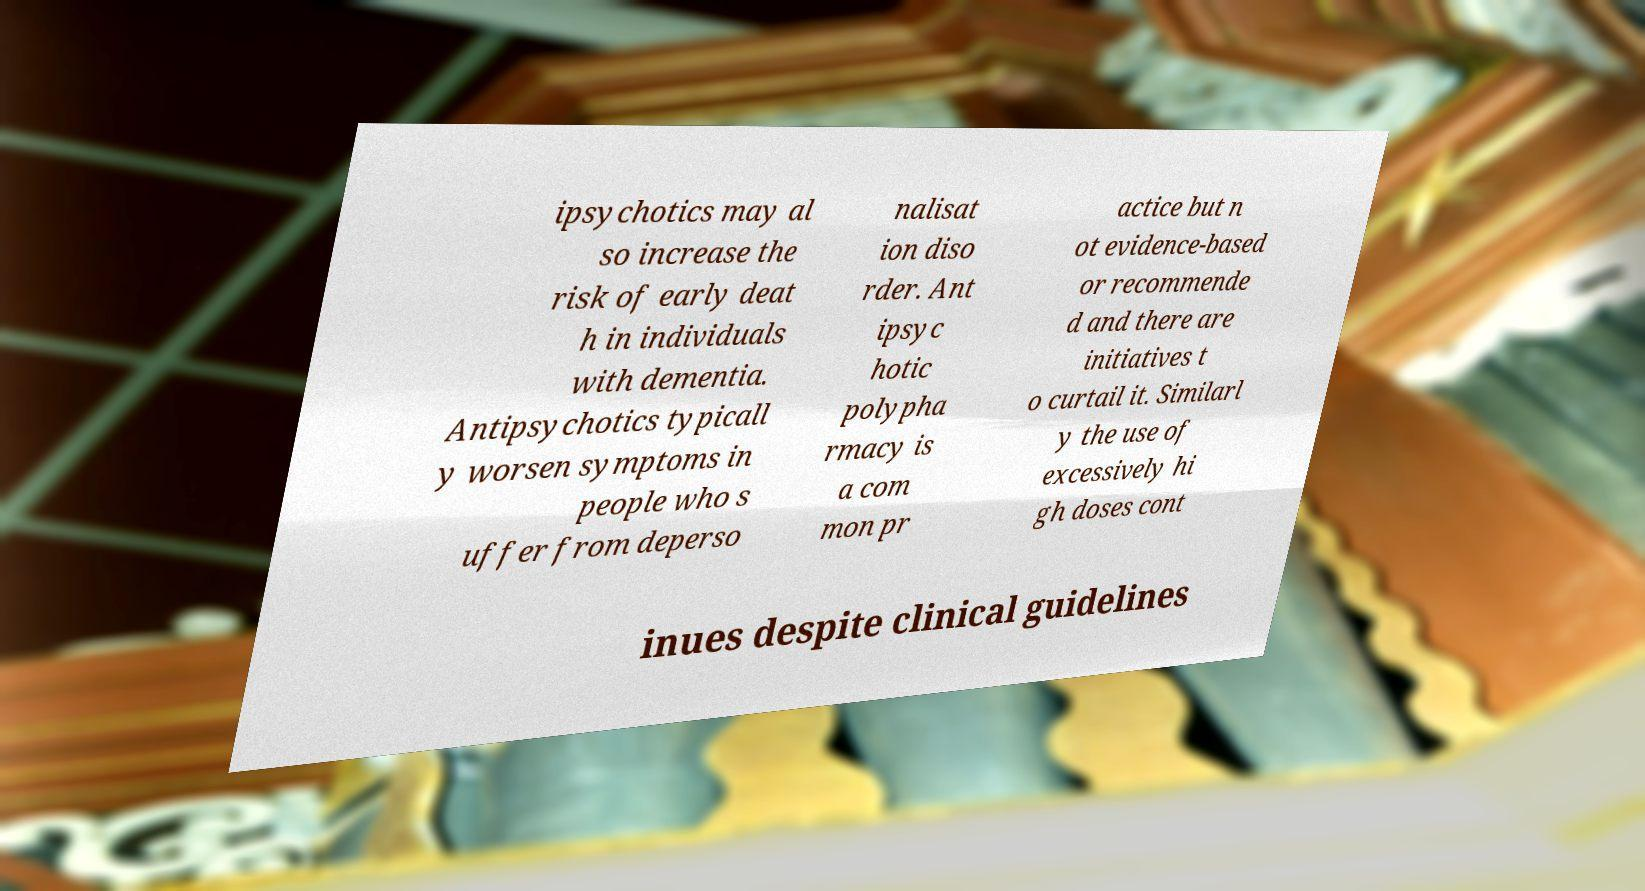Could you assist in decoding the text presented in this image and type it out clearly? ipsychotics may al so increase the risk of early deat h in individuals with dementia. Antipsychotics typicall y worsen symptoms in people who s uffer from deperso nalisat ion diso rder. Ant ipsyc hotic polypha rmacy is a com mon pr actice but n ot evidence-based or recommende d and there are initiatives t o curtail it. Similarl y the use of excessively hi gh doses cont inues despite clinical guidelines 